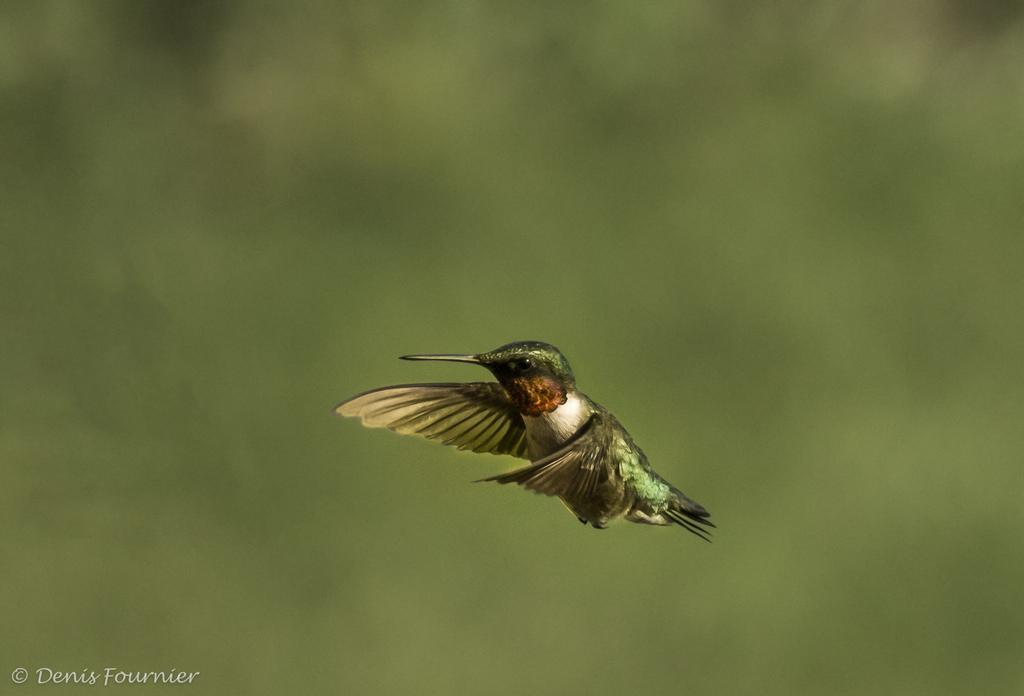How would you summarize this image in a sentence or two? This image consists of a bird in green color. And we can see a sharp beak. In the background, we can see green color. And the background is blurred. 